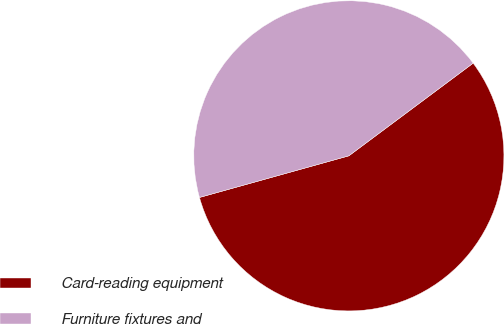Convert chart to OTSL. <chart><loc_0><loc_0><loc_500><loc_500><pie_chart><fcel>Card-reading equipment<fcel>Furniture fixtures and<nl><fcel>55.87%<fcel>44.13%<nl></chart> 